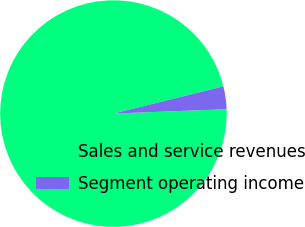<chart> <loc_0><loc_0><loc_500><loc_500><pie_chart><fcel>Sales and service revenues<fcel>Segment operating income<nl><fcel>96.75%<fcel>3.25%<nl></chart> 